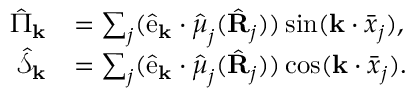<formula> <loc_0><loc_0><loc_500><loc_500>\begin{array} { r l } { \hat { \Pi } _ { k } } & { = \sum _ { j } ( \hat { e } _ { k } \cdot \hat { \boldsymbol \mu } _ { j } ( \hat { R } _ { j } ) ) \sin ( k \cdot \bar { \boldsymbol x } _ { j } ) , } \\ { \hat { \mathcal { S } } _ { k } } & { = \sum _ { j } ( \hat { e } _ { k } \cdot \hat { \boldsymbol \mu } _ { j } ( \hat { R } _ { j } ) ) \cos ( k \cdot \bar { \boldsymbol x } _ { j } ) . } \end{array}</formula> 